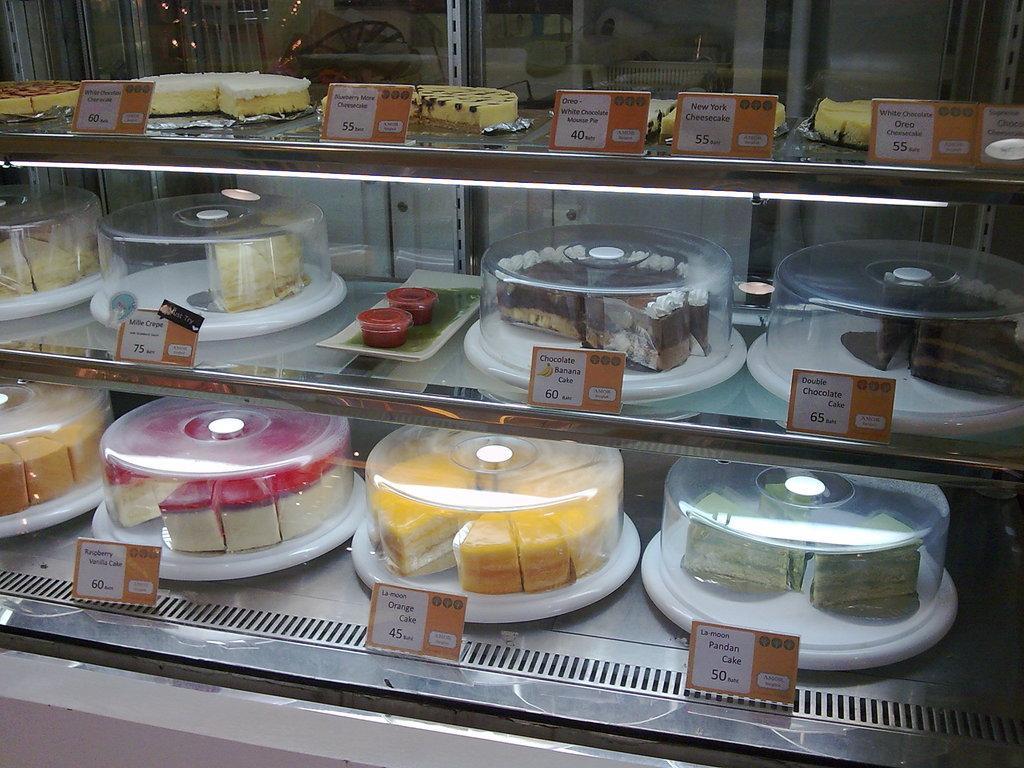Could you give a brief overview of what you see in this image? In this image in the center there is one glass box, in that box there are some cakes and pastries and some boards. On the boards there is some text, and in the background there is a glass door. 